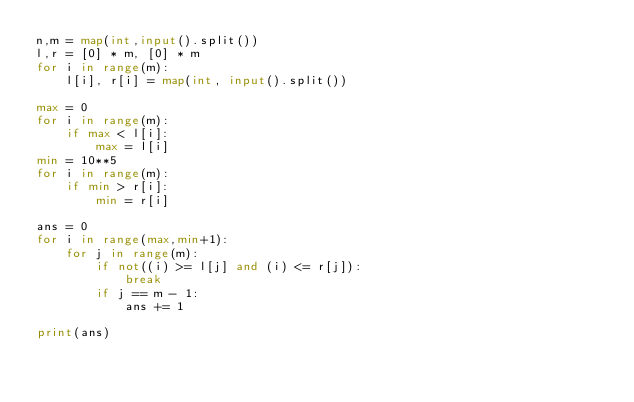Convert code to text. <code><loc_0><loc_0><loc_500><loc_500><_Python_>n,m = map(int,input().split())
l,r = [0] * m, [0] * m
for i in range(m):
    l[i], r[i] = map(int, input().split())

max = 0
for i in range(m):
    if max < l[i]:
        max = l[i]
min = 10**5
for i in range(m):
    if min > r[i]:
        min = r[i]

ans = 0
for i in range(max,min+1):
    for j in range(m):
        if not((i) >= l[j] and (i) <= r[j]):
            break
        if j == m - 1:
            ans += 1

print(ans)</code> 